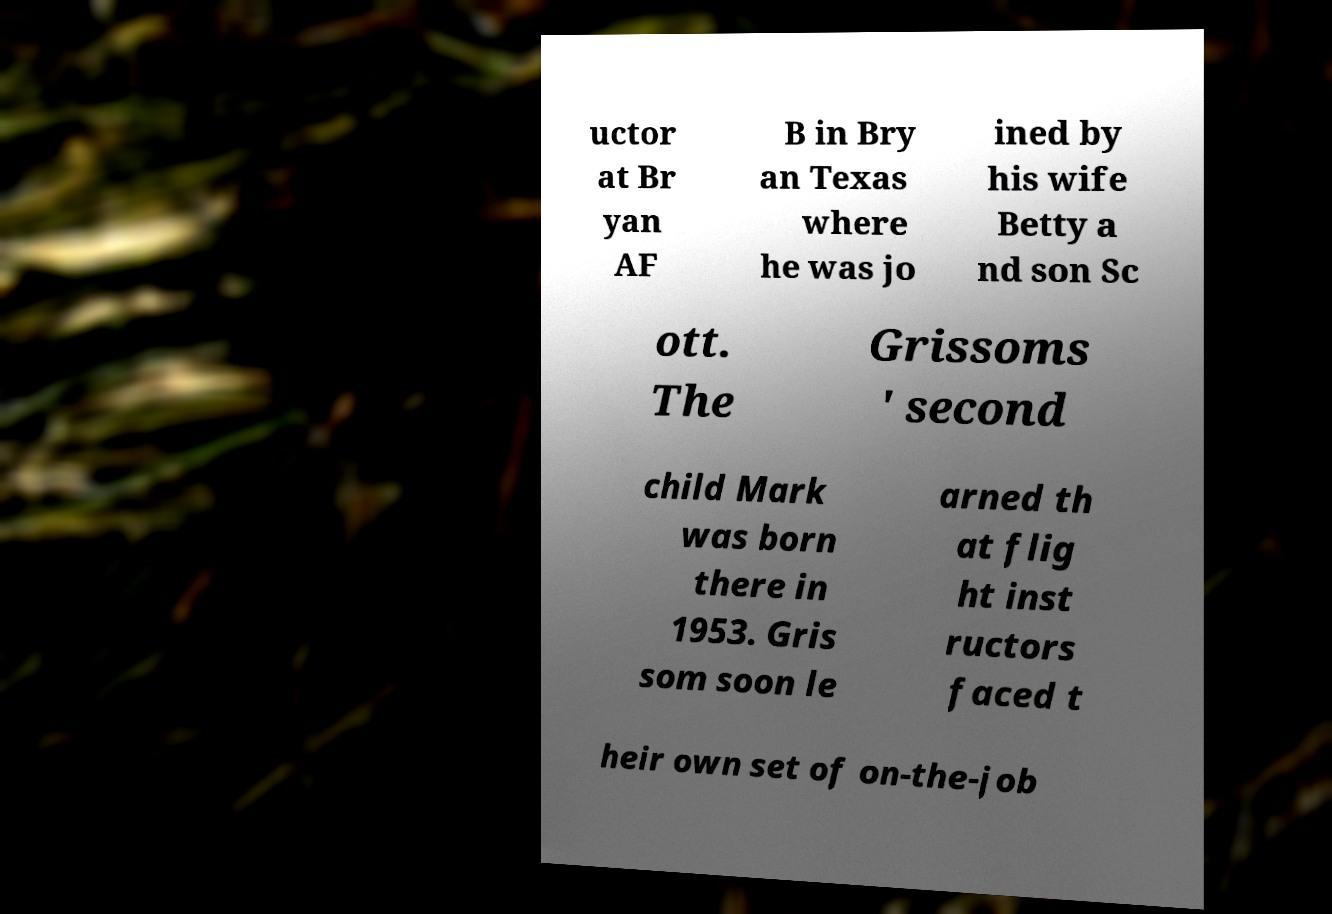What messages or text are displayed in this image? I need them in a readable, typed format. uctor at Br yan AF B in Bry an Texas where he was jo ined by his wife Betty a nd son Sc ott. The Grissoms ' second child Mark was born there in 1953. Gris som soon le arned th at flig ht inst ructors faced t heir own set of on-the-job 